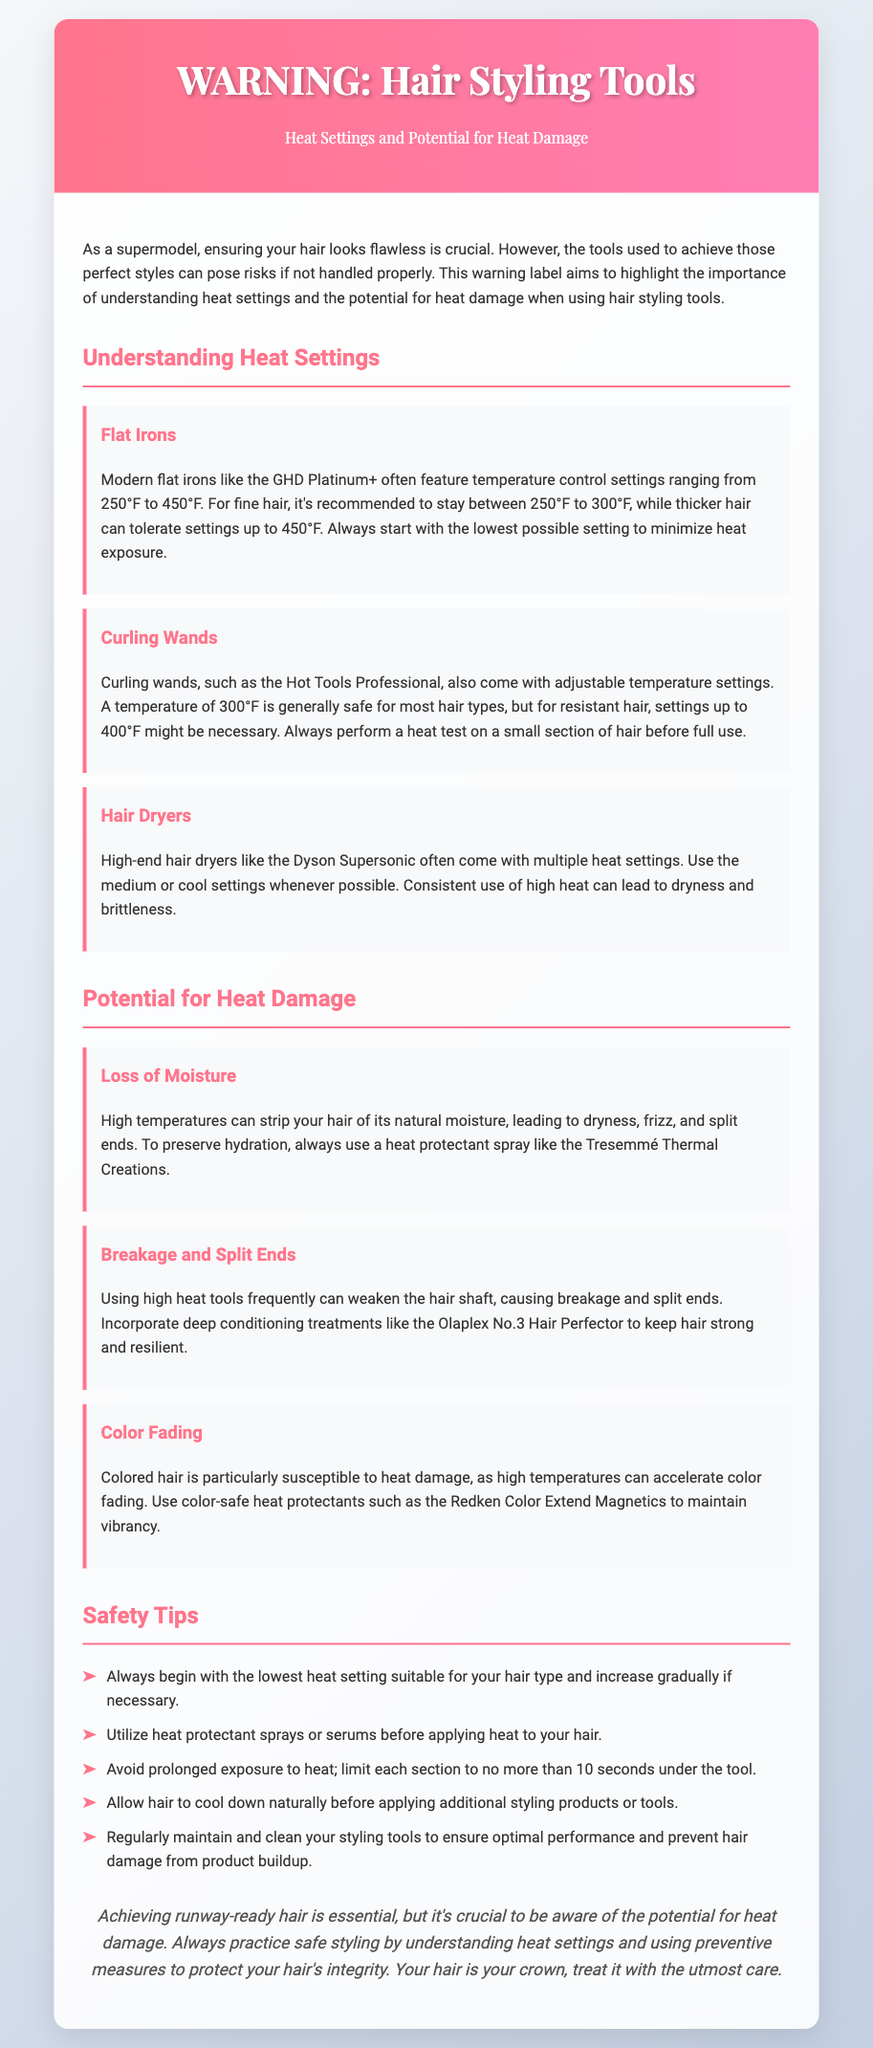What is the temperature range for flat irons? The document states that modern flat irons feature temperature control settings ranging from 250°F to 450°F.
Answer: 250°F to 450°F What is the recommended temperature for fine hair? It is recommended to stay between 250°F to 300°F for fine hair.
Answer: 250°F to 300°F What potential issue is caused by high temperatures? High temperatures can strip your hair of its natural moisture, leading to dryness, frizz, and split ends.
Answer: Loss of Moisture Which tool has adjustable temperature settings? Both curling wands and flat irons come with adjustable temperature settings.
Answer: Curling wands and flat irons What should be used to protect hair before heat styling? The document suggests using a heat protectant spray like Tresemmé Thermal Creations before applying heat.
Answer: Heat protectant spray What is the maximum time a section should be under heat? The document advises limiting each section to no more than 10 seconds under the tool.
Answer: 10 seconds What treatment can help maintain hair strength? Incorporating deep conditioning treatments like Olaplex No.3 Hair Perfector can keep hair strong and resilient.
Answer: Olaplex No.3 Hair Perfector What can accelerate color fading in hair? High temperatures can accelerate color fading, especially in colored hair.
Answer: High temperatures 